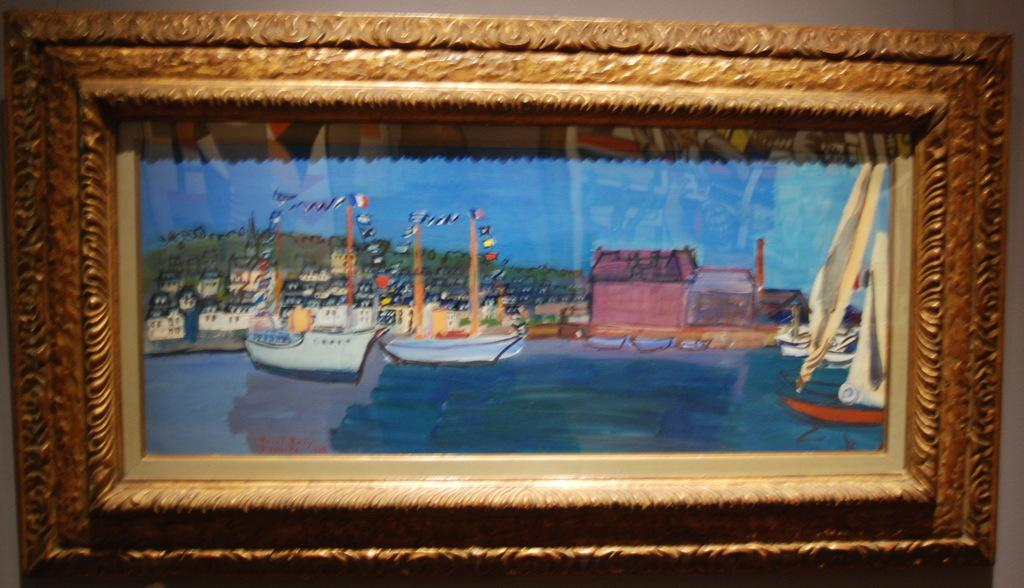What is the main subject of the image? There is a painting in the image. What does the painting depict? The painting depicts buildings, a hill, and boats on water. What is visible in the sky in the painting? The sky is visible in the painting. How is the painting displayed in the image? The painting is on a photo frame, and the photo frame is attached to an object. What type of growth can be seen on the earth in the image? There is no earth or growth present in the image; it features a painting of a landscape with buildings, a hill, boats, and sky. 